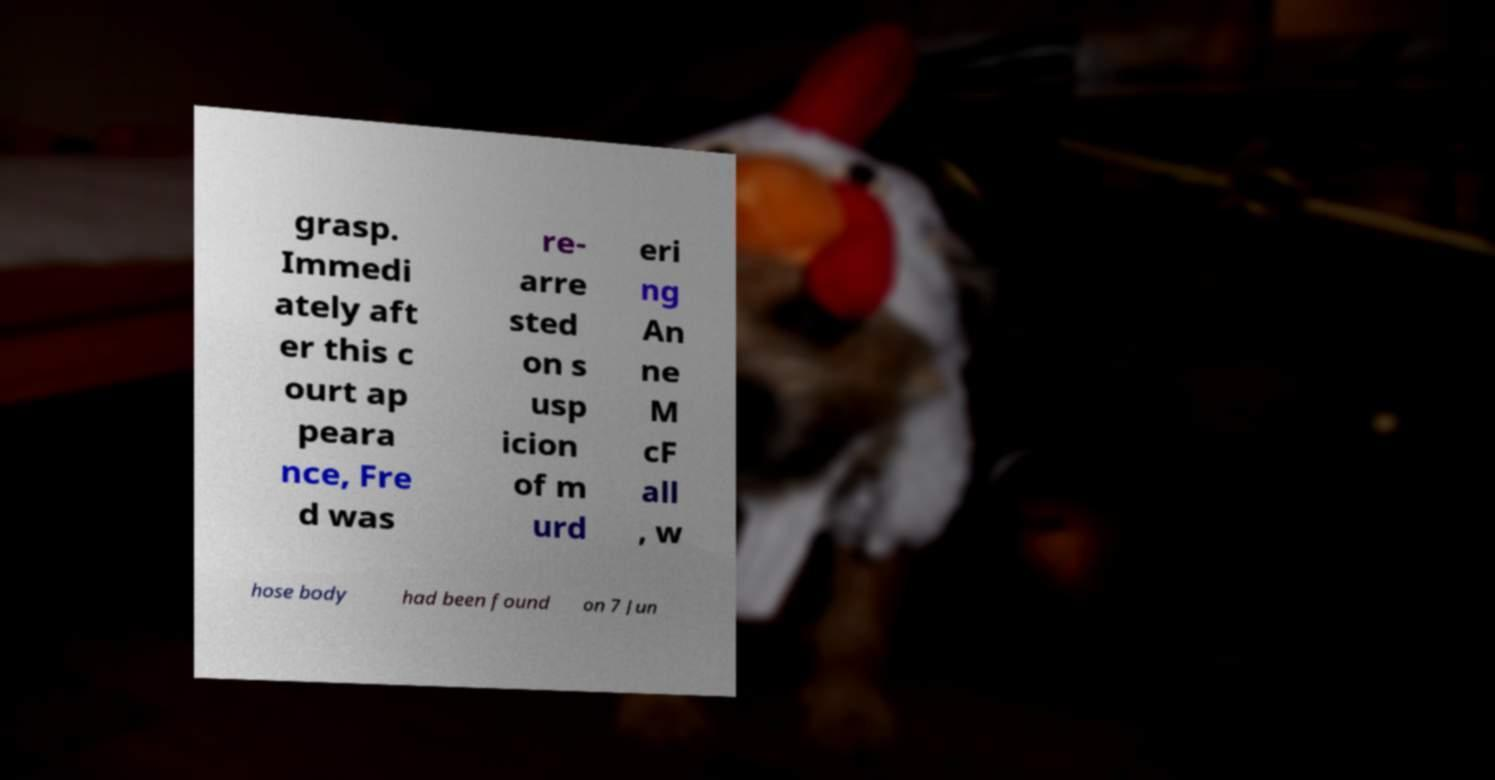I need the written content from this picture converted into text. Can you do that? grasp. Immedi ately aft er this c ourt ap peara nce, Fre d was re- arre sted on s usp icion of m urd eri ng An ne M cF all , w hose body had been found on 7 Jun 